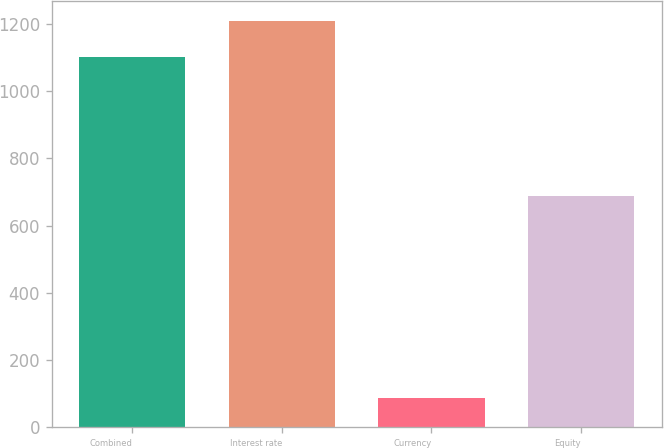Convert chart. <chart><loc_0><loc_0><loc_500><loc_500><bar_chart><fcel>Combined<fcel>Interest rate<fcel>Currency<fcel>Equity<nl><fcel>1100<fcel>1208.5<fcel>88<fcel>688<nl></chart> 